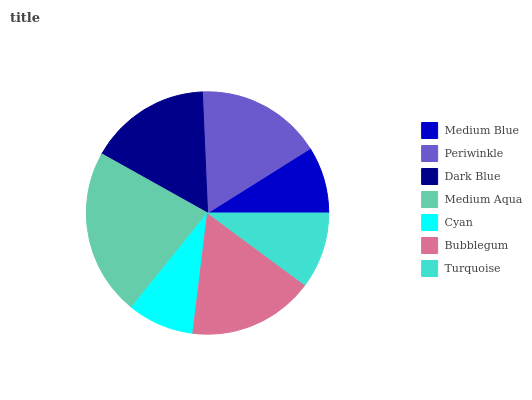Is Cyan the minimum?
Answer yes or no. Yes. Is Medium Aqua the maximum?
Answer yes or no. Yes. Is Periwinkle the minimum?
Answer yes or no. No. Is Periwinkle the maximum?
Answer yes or no. No. Is Periwinkle greater than Medium Blue?
Answer yes or no. Yes. Is Medium Blue less than Periwinkle?
Answer yes or no. Yes. Is Medium Blue greater than Periwinkle?
Answer yes or no. No. Is Periwinkle less than Medium Blue?
Answer yes or no. No. Is Dark Blue the high median?
Answer yes or no. Yes. Is Dark Blue the low median?
Answer yes or no. Yes. Is Cyan the high median?
Answer yes or no. No. Is Turquoise the low median?
Answer yes or no. No. 